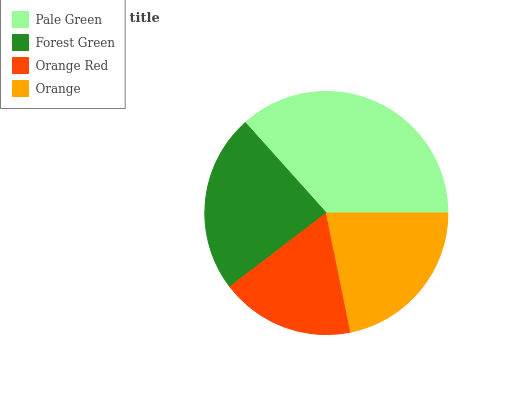Is Orange Red the minimum?
Answer yes or no. Yes. Is Pale Green the maximum?
Answer yes or no. Yes. Is Forest Green the minimum?
Answer yes or no. No. Is Forest Green the maximum?
Answer yes or no. No. Is Pale Green greater than Forest Green?
Answer yes or no. Yes. Is Forest Green less than Pale Green?
Answer yes or no. Yes. Is Forest Green greater than Pale Green?
Answer yes or no. No. Is Pale Green less than Forest Green?
Answer yes or no. No. Is Forest Green the high median?
Answer yes or no. Yes. Is Orange the low median?
Answer yes or no. Yes. Is Orange the high median?
Answer yes or no. No. Is Orange Red the low median?
Answer yes or no. No. 